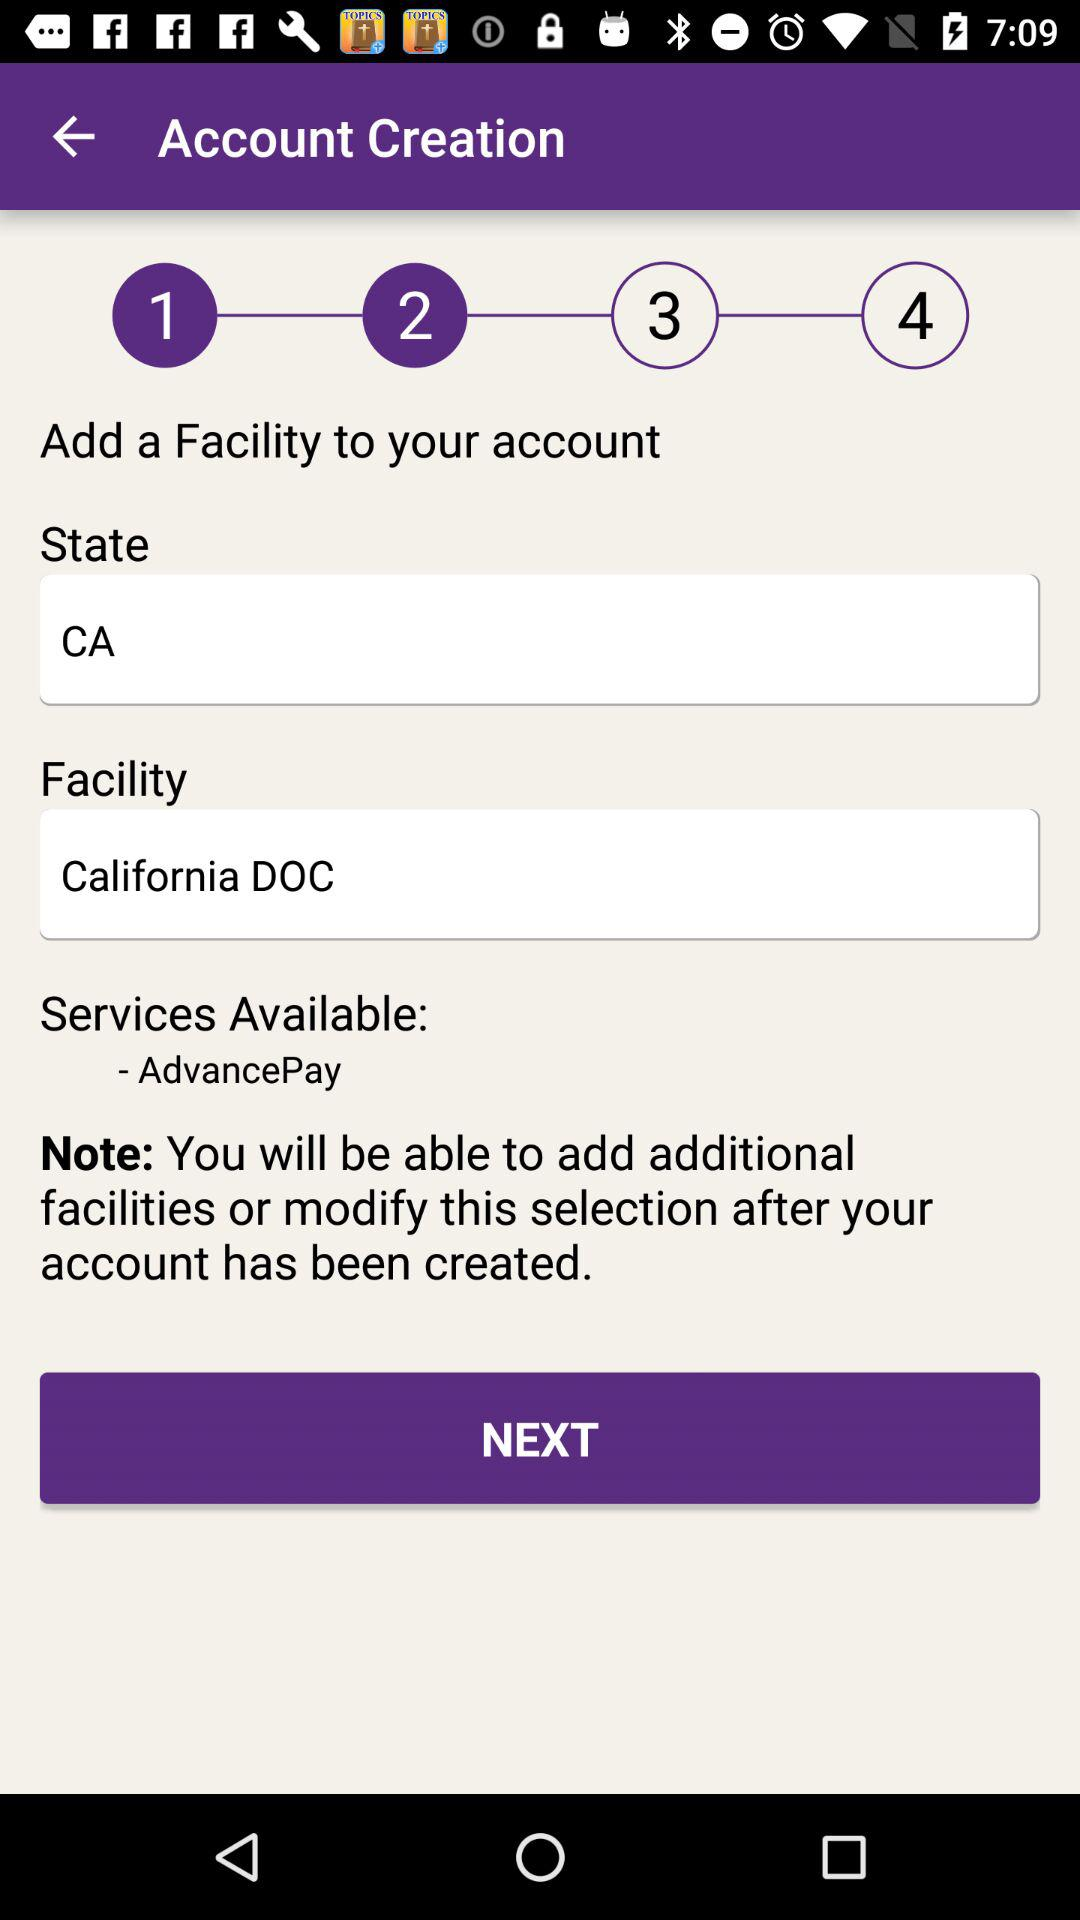Which facility is mentioned? The mentioned facility is the California DOC. 